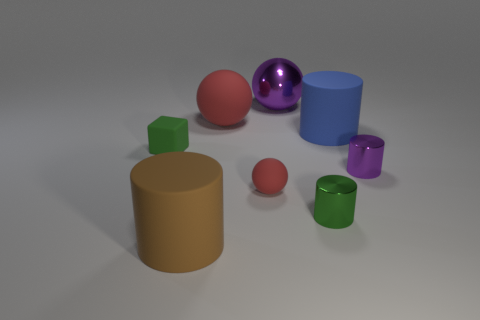What size is the metal cylinder that is the same color as the tiny matte cube?
Your response must be concise. Small. What color is the small matte thing that is right of the big rubber ball?
Your answer should be very brief. Red. What size is the brown thing that is the same shape as the small green metallic object?
Keep it short and to the point. Large. What number of things are red things behind the green block or matte objects to the right of the brown object?
Your answer should be compact. 3. There is a object that is both left of the large red thing and in front of the small green cube; what size is it?
Offer a terse response. Large. There is a small red object; is it the same shape as the big red thing that is on the left side of the large purple object?
Your answer should be compact. Yes. What number of things are small green things right of the tiny matte ball or big matte objects?
Your response must be concise. 4. Is the material of the tiny purple object the same as the small green object that is in front of the green cube?
Make the answer very short. Yes. The tiny green object left of the shiny thing that is behind the blue cylinder is what shape?
Provide a succinct answer. Cube. Do the tiny rubber ball and the metallic cylinder behind the tiny red matte thing have the same color?
Provide a succinct answer. No. 